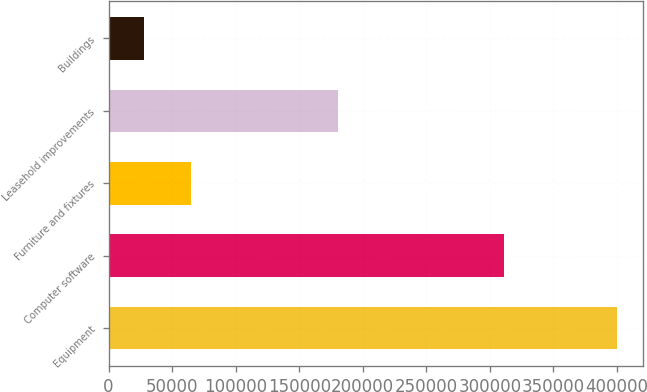<chart> <loc_0><loc_0><loc_500><loc_500><bar_chart><fcel>Equipment<fcel>Computer software<fcel>Furniture and fixtures<fcel>Leasehold improvements<fcel>Buildings<nl><fcel>400111<fcel>310789<fcel>64995.1<fcel>180621<fcel>27760<nl></chart> 